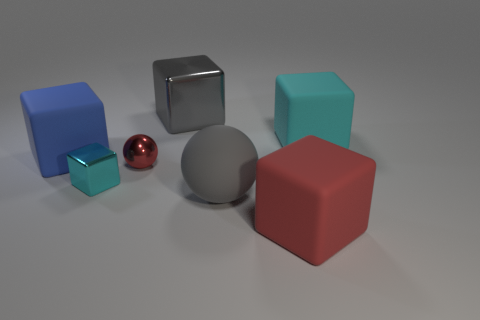Subtract all big blue cubes. How many cubes are left? 4 Subtract all red spheres. How many spheres are left? 1 Add 3 large green metal objects. How many objects exist? 10 Subtract all spheres. How many objects are left? 5 Subtract 5 cubes. How many cubes are left? 0 Subtract all blue matte cylinders. Subtract all cyan matte cubes. How many objects are left? 6 Add 1 small red shiny things. How many small red shiny things are left? 2 Add 2 gray metal balls. How many gray metal balls exist? 2 Subtract 0 yellow cubes. How many objects are left? 7 Subtract all purple balls. Subtract all green blocks. How many balls are left? 2 